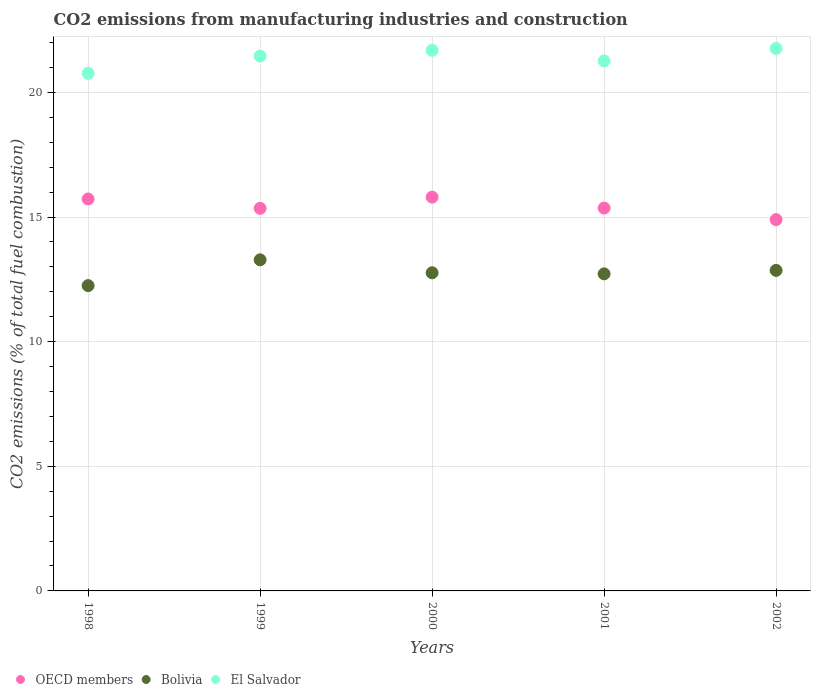How many different coloured dotlines are there?
Your answer should be compact. 3. Is the number of dotlines equal to the number of legend labels?
Offer a very short reply. Yes. What is the amount of CO2 emitted in Bolivia in 1998?
Provide a succinct answer. 12.25. Across all years, what is the maximum amount of CO2 emitted in El Salvador?
Provide a short and direct response. 21.76. Across all years, what is the minimum amount of CO2 emitted in El Salvador?
Make the answer very short. 20.76. In which year was the amount of CO2 emitted in El Salvador maximum?
Offer a very short reply. 2002. What is the total amount of CO2 emitted in Bolivia in the graph?
Your answer should be very brief. 63.87. What is the difference between the amount of CO2 emitted in Bolivia in 1998 and that in 2002?
Provide a short and direct response. -0.61. What is the difference between the amount of CO2 emitted in Bolivia in 2002 and the amount of CO2 emitted in El Salvador in 1999?
Ensure brevity in your answer.  -8.6. What is the average amount of CO2 emitted in El Salvador per year?
Provide a short and direct response. 21.39. In the year 1999, what is the difference between the amount of CO2 emitted in Bolivia and amount of CO2 emitted in OECD members?
Your answer should be very brief. -2.07. What is the ratio of the amount of CO2 emitted in Bolivia in 2001 to that in 2002?
Provide a short and direct response. 0.99. Is the amount of CO2 emitted in El Salvador in 2000 less than that in 2002?
Make the answer very short. Yes. What is the difference between the highest and the second highest amount of CO2 emitted in El Salvador?
Your response must be concise. 0.07. What is the difference between the highest and the lowest amount of CO2 emitted in El Salvador?
Keep it short and to the point. 1. In how many years, is the amount of CO2 emitted in Bolivia greater than the average amount of CO2 emitted in Bolivia taken over all years?
Provide a succinct answer. 2. Is it the case that in every year, the sum of the amount of CO2 emitted in OECD members and amount of CO2 emitted in El Salvador  is greater than the amount of CO2 emitted in Bolivia?
Ensure brevity in your answer.  Yes. Does the amount of CO2 emitted in El Salvador monotonically increase over the years?
Give a very brief answer. No. Is the amount of CO2 emitted in El Salvador strictly less than the amount of CO2 emitted in Bolivia over the years?
Give a very brief answer. No. How many years are there in the graph?
Your response must be concise. 5. What is the difference between two consecutive major ticks on the Y-axis?
Offer a very short reply. 5. Does the graph contain any zero values?
Provide a short and direct response. No. Does the graph contain grids?
Ensure brevity in your answer.  Yes. How many legend labels are there?
Your answer should be very brief. 3. How are the legend labels stacked?
Provide a succinct answer. Horizontal. What is the title of the graph?
Provide a short and direct response. CO2 emissions from manufacturing industries and construction. Does "Middle East & North Africa (all income levels)" appear as one of the legend labels in the graph?
Ensure brevity in your answer.  No. What is the label or title of the Y-axis?
Provide a short and direct response. CO2 emissions (% of total fuel combustion). What is the CO2 emissions (% of total fuel combustion) of OECD members in 1998?
Offer a very short reply. 15.72. What is the CO2 emissions (% of total fuel combustion) in Bolivia in 1998?
Your answer should be compact. 12.25. What is the CO2 emissions (% of total fuel combustion) in El Salvador in 1998?
Provide a short and direct response. 20.76. What is the CO2 emissions (% of total fuel combustion) in OECD members in 1999?
Your answer should be very brief. 15.35. What is the CO2 emissions (% of total fuel combustion) of Bolivia in 1999?
Keep it short and to the point. 13.28. What is the CO2 emissions (% of total fuel combustion) of El Salvador in 1999?
Give a very brief answer. 21.46. What is the CO2 emissions (% of total fuel combustion) in OECD members in 2000?
Make the answer very short. 15.8. What is the CO2 emissions (% of total fuel combustion) of Bolivia in 2000?
Your response must be concise. 12.76. What is the CO2 emissions (% of total fuel combustion) in El Salvador in 2000?
Provide a succinct answer. 21.69. What is the CO2 emissions (% of total fuel combustion) in OECD members in 2001?
Offer a terse response. 15.36. What is the CO2 emissions (% of total fuel combustion) in Bolivia in 2001?
Make the answer very short. 12.72. What is the CO2 emissions (% of total fuel combustion) of El Salvador in 2001?
Offer a terse response. 21.26. What is the CO2 emissions (% of total fuel combustion) in OECD members in 2002?
Make the answer very short. 14.9. What is the CO2 emissions (% of total fuel combustion) of Bolivia in 2002?
Your answer should be compact. 12.86. What is the CO2 emissions (% of total fuel combustion) of El Salvador in 2002?
Offer a terse response. 21.76. Across all years, what is the maximum CO2 emissions (% of total fuel combustion) of OECD members?
Ensure brevity in your answer.  15.8. Across all years, what is the maximum CO2 emissions (% of total fuel combustion) in Bolivia?
Ensure brevity in your answer.  13.28. Across all years, what is the maximum CO2 emissions (% of total fuel combustion) of El Salvador?
Offer a terse response. 21.76. Across all years, what is the minimum CO2 emissions (% of total fuel combustion) of OECD members?
Your response must be concise. 14.9. Across all years, what is the minimum CO2 emissions (% of total fuel combustion) in Bolivia?
Provide a short and direct response. 12.25. Across all years, what is the minimum CO2 emissions (% of total fuel combustion) of El Salvador?
Keep it short and to the point. 20.76. What is the total CO2 emissions (% of total fuel combustion) in OECD members in the graph?
Make the answer very short. 77.12. What is the total CO2 emissions (% of total fuel combustion) in Bolivia in the graph?
Your answer should be very brief. 63.87. What is the total CO2 emissions (% of total fuel combustion) of El Salvador in the graph?
Your response must be concise. 106.93. What is the difference between the CO2 emissions (% of total fuel combustion) of OECD members in 1998 and that in 1999?
Offer a very short reply. 0.38. What is the difference between the CO2 emissions (% of total fuel combustion) of Bolivia in 1998 and that in 1999?
Provide a short and direct response. -1.03. What is the difference between the CO2 emissions (% of total fuel combustion) of El Salvador in 1998 and that in 1999?
Make the answer very short. -0.69. What is the difference between the CO2 emissions (% of total fuel combustion) of OECD members in 1998 and that in 2000?
Your response must be concise. -0.07. What is the difference between the CO2 emissions (% of total fuel combustion) of Bolivia in 1998 and that in 2000?
Keep it short and to the point. -0.52. What is the difference between the CO2 emissions (% of total fuel combustion) in El Salvador in 1998 and that in 2000?
Provide a succinct answer. -0.93. What is the difference between the CO2 emissions (% of total fuel combustion) of OECD members in 1998 and that in 2001?
Ensure brevity in your answer.  0.37. What is the difference between the CO2 emissions (% of total fuel combustion) in Bolivia in 1998 and that in 2001?
Give a very brief answer. -0.47. What is the difference between the CO2 emissions (% of total fuel combustion) in El Salvador in 1998 and that in 2001?
Give a very brief answer. -0.5. What is the difference between the CO2 emissions (% of total fuel combustion) of OECD members in 1998 and that in 2002?
Provide a short and direct response. 0.83. What is the difference between the CO2 emissions (% of total fuel combustion) of Bolivia in 1998 and that in 2002?
Offer a terse response. -0.61. What is the difference between the CO2 emissions (% of total fuel combustion) of El Salvador in 1998 and that in 2002?
Your answer should be very brief. -1. What is the difference between the CO2 emissions (% of total fuel combustion) of OECD members in 1999 and that in 2000?
Keep it short and to the point. -0.45. What is the difference between the CO2 emissions (% of total fuel combustion) of Bolivia in 1999 and that in 2000?
Provide a short and direct response. 0.52. What is the difference between the CO2 emissions (% of total fuel combustion) in El Salvador in 1999 and that in 2000?
Your answer should be compact. -0.23. What is the difference between the CO2 emissions (% of total fuel combustion) in OECD members in 1999 and that in 2001?
Make the answer very short. -0.01. What is the difference between the CO2 emissions (% of total fuel combustion) of Bolivia in 1999 and that in 2001?
Give a very brief answer. 0.56. What is the difference between the CO2 emissions (% of total fuel combustion) in El Salvador in 1999 and that in 2001?
Offer a very short reply. 0.19. What is the difference between the CO2 emissions (% of total fuel combustion) in OECD members in 1999 and that in 2002?
Your answer should be very brief. 0.45. What is the difference between the CO2 emissions (% of total fuel combustion) in Bolivia in 1999 and that in 2002?
Keep it short and to the point. 0.42. What is the difference between the CO2 emissions (% of total fuel combustion) of El Salvador in 1999 and that in 2002?
Make the answer very short. -0.31. What is the difference between the CO2 emissions (% of total fuel combustion) in OECD members in 2000 and that in 2001?
Your answer should be compact. 0.44. What is the difference between the CO2 emissions (% of total fuel combustion) in Bolivia in 2000 and that in 2001?
Offer a terse response. 0.04. What is the difference between the CO2 emissions (% of total fuel combustion) in El Salvador in 2000 and that in 2001?
Offer a very short reply. 0.43. What is the difference between the CO2 emissions (% of total fuel combustion) in OECD members in 2000 and that in 2002?
Offer a terse response. 0.9. What is the difference between the CO2 emissions (% of total fuel combustion) in Bolivia in 2000 and that in 2002?
Provide a succinct answer. -0.1. What is the difference between the CO2 emissions (% of total fuel combustion) of El Salvador in 2000 and that in 2002?
Keep it short and to the point. -0.07. What is the difference between the CO2 emissions (% of total fuel combustion) in OECD members in 2001 and that in 2002?
Your response must be concise. 0.46. What is the difference between the CO2 emissions (% of total fuel combustion) in Bolivia in 2001 and that in 2002?
Provide a short and direct response. -0.14. What is the difference between the CO2 emissions (% of total fuel combustion) in El Salvador in 2001 and that in 2002?
Your response must be concise. -0.5. What is the difference between the CO2 emissions (% of total fuel combustion) of OECD members in 1998 and the CO2 emissions (% of total fuel combustion) of Bolivia in 1999?
Offer a very short reply. 2.44. What is the difference between the CO2 emissions (% of total fuel combustion) of OECD members in 1998 and the CO2 emissions (% of total fuel combustion) of El Salvador in 1999?
Your response must be concise. -5.73. What is the difference between the CO2 emissions (% of total fuel combustion) of Bolivia in 1998 and the CO2 emissions (% of total fuel combustion) of El Salvador in 1999?
Provide a succinct answer. -9.21. What is the difference between the CO2 emissions (% of total fuel combustion) in OECD members in 1998 and the CO2 emissions (% of total fuel combustion) in Bolivia in 2000?
Your answer should be compact. 2.96. What is the difference between the CO2 emissions (% of total fuel combustion) in OECD members in 1998 and the CO2 emissions (% of total fuel combustion) in El Salvador in 2000?
Keep it short and to the point. -5.97. What is the difference between the CO2 emissions (% of total fuel combustion) in Bolivia in 1998 and the CO2 emissions (% of total fuel combustion) in El Salvador in 2000?
Give a very brief answer. -9.44. What is the difference between the CO2 emissions (% of total fuel combustion) in OECD members in 1998 and the CO2 emissions (% of total fuel combustion) in Bolivia in 2001?
Offer a terse response. 3. What is the difference between the CO2 emissions (% of total fuel combustion) of OECD members in 1998 and the CO2 emissions (% of total fuel combustion) of El Salvador in 2001?
Offer a very short reply. -5.54. What is the difference between the CO2 emissions (% of total fuel combustion) of Bolivia in 1998 and the CO2 emissions (% of total fuel combustion) of El Salvador in 2001?
Make the answer very short. -9.01. What is the difference between the CO2 emissions (% of total fuel combustion) in OECD members in 1998 and the CO2 emissions (% of total fuel combustion) in Bolivia in 2002?
Your answer should be very brief. 2.86. What is the difference between the CO2 emissions (% of total fuel combustion) of OECD members in 1998 and the CO2 emissions (% of total fuel combustion) of El Salvador in 2002?
Your answer should be very brief. -6.04. What is the difference between the CO2 emissions (% of total fuel combustion) in Bolivia in 1998 and the CO2 emissions (% of total fuel combustion) in El Salvador in 2002?
Provide a short and direct response. -9.51. What is the difference between the CO2 emissions (% of total fuel combustion) in OECD members in 1999 and the CO2 emissions (% of total fuel combustion) in Bolivia in 2000?
Your answer should be compact. 2.58. What is the difference between the CO2 emissions (% of total fuel combustion) in OECD members in 1999 and the CO2 emissions (% of total fuel combustion) in El Salvador in 2000?
Provide a succinct answer. -6.34. What is the difference between the CO2 emissions (% of total fuel combustion) in Bolivia in 1999 and the CO2 emissions (% of total fuel combustion) in El Salvador in 2000?
Ensure brevity in your answer.  -8.41. What is the difference between the CO2 emissions (% of total fuel combustion) in OECD members in 1999 and the CO2 emissions (% of total fuel combustion) in Bolivia in 2001?
Offer a terse response. 2.63. What is the difference between the CO2 emissions (% of total fuel combustion) of OECD members in 1999 and the CO2 emissions (% of total fuel combustion) of El Salvador in 2001?
Your answer should be very brief. -5.91. What is the difference between the CO2 emissions (% of total fuel combustion) in Bolivia in 1999 and the CO2 emissions (% of total fuel combustion) in El Salvador in 2001?
Ensure brevity in your answer.  -7.98. What is the difference between the CO2 emissions (% of total fuel combustion) in OECD members in 1999 and the CO2 emissions (% of total fuel combustion) in Bolivia in 2002?
Your response must be concise. 2.49. What is the difference between the CO2 emissions (% of total fuel combustion) in OECD members in 1999 and the CO2 emissions (% of total fuel combustion) in El Salvador in 2002?
Give a very brief answer. -6.41. What is the difference between the CO2 emissions (% of total fuel combustion) of Bolivia in 1999 and the CO2 emissions (% of total fuel combustion) of El Salvador in 2002?
Your answer should be compact. -8.48. What is the difference between the CO2 emissions (% of total fuel combustion) in OECD members in 2000 and the CO2 emissions (% of total fuel combustion) in Bolivia in 2001?
Your answer should be compact. 3.08. What is the difference between the CO2 emissions (% of total fuel combustion) of OECD members in 2000 and the CO2 emissions (% of total fuel combustion) of El Salvador in 2001?
Keep it short and to the point. -5.46. What is the difference between the CO2 emissions (% of total fuel combustion) in Bolivia in 2000 and the CO2 emissions (% of total fuel combustion) in El Salvador in 2001?
Make the answer very short. -8.5. What is the difference between the CO2 emissions (% of total fuel combustion) of OECD members in 2000 and the CO2 emissions (% of total fuel combustion) of Bolivia in 2002?
Ensure brevity in your answer.  2.94. What is the difference between the CO2 emissions (% of total fuel combustion) of OECD members in 2000 and the CO2 emissions (% of total fuel combustion) of El Salvador in 2002?
Give a very brief answer. -5.96. What is the difference between the CO2 emissions (% of total fuel combustion) in Bolivia in 2000 and the CO2 emissions (% of total fuel combustion) in El Salvador in 2002?
Your answer should be very brief. -9. What is the difference between the CO2 emissions (% of total fuel combustion) in OECD members in 2001 and the CO2 emissions (% of total fuel combustion) in Bolivia in 2002?
Provide a succinct answer. 2.5. What is the difference between the CO2 emissions (% of total fuel combustion) in OECD members in 2001 and the CO2 emissions (% of total fuel combustion) in El Salvador in 2002?
Ensure brevity in your answer.  -6.4. What is the difference between the CO2 emissions (% of total fuel combustion) in Bolivia in 2001 and the CO2 emissions (% of total fuel combustion) in El Salvador in 2002?
Your answer should be very brief. -9.04. What is the average CO2 emissions (% of total fuel combustion) in OECD members per year?
Provide a succinct answer. 15.42. What is the average CO2 emissions (% of total fuel combustion) in Bolivia per year?
Ensure brevity in your answer.  12.77. What is the average CO2 emissions (% of total fuel combustion) in El Salvador per year?
Your response must be concise. 21.39. In the year 1998, what is the difference between the CO2 emissions (% of total fuel combustion) of OECD members and CO2 emissions (% of total fuel combustion) of Bolivia?
Your response must be concise. 3.48. In the year 1998, what is the difference between the CO2 emissions (% of total fuel combustion) of OECD members and CO2 emissions (% of total fuel combustion) of El Salvador?
Offer a terse response. -5.04. In the year 1998, what is the difference between the CO2 emissions (% of total fuel combustion) of Bolivia and CO2 emissions (% of total fuel combustion) of El Salvador?
Provide a short and direct response. -8.51. In the year 1999, what is the difference between the CO2 emissions (% of total fuel combustion) in OECD members and CO2 emissions (% of total fuel combustion) in Bolivia?
Your answer should be very brief. 2.07. In the year 1999, what is the difference between the CO2 emissions (% of total fuel combustion) in OECD members and CO2 emissions (% of total fuel combustion) in El Salvador?
Your answer should be very brief. -6.11. In the year 1999, what is the difference between the CO2 emissions (% of total fuel combustion) in Bolivia and CO2 emissions (% of total fuel combustion) in El Salvador?
Your response must be concise. -8.17. In the year 2000, what is the difference between the CO2 emissions (% of total fuel combustion) of OECD members and CO2 emissions (% of total fuel combustion) of Bolivia?
Provide a short and direct response. 3.03. In the year 2000, what is the difference between the CO2 emissions (% of total fuel combustion) of OECD members and CO2 emissions (% of total fuel combustion) of El Salvador?
Offer a very short reply. -5.89. In the year 2000, what is the difference between the CO2 emissions (% of total fuel combustion) in Bolivia and CO2 emissions (% of total fuel combustion) in El Salvador?
Provide a succinct answer. -8.93. In the year 2001, what is the difference between the CO2 emissions (% of total fuel combustion) in OECD members and CO2 emissions (% of total fuel combustion) in Bolivia?
Your answer should be compact. 2.64. In the year 2001, what is the difference between the CO2 emissions (% of total fuel combustion) of OECD members and CO2 emissions (% of total fuel combustion) of El Salvador?
Offer a terse response. -5.9. In the year 2001, what is the difference between the CO2 emissions (% of total fuel combustion) in Bolivia and CO2 emissions (% of total fuel combustion) in El Salvador?
Offer a very short reply. -8.54. In the year 2002, what is the difference between the CO2 emissions (% of total fuel combustion) of OECD members and CO2 emissions (% of total fuel combustion) of Bolivia?
Make the answer very short. 2.04. In the year 2002, what is the difference between the CO2 emissions (% of total fuel combustion) in OECD members and CO2 emissions (% of total fuel combustion) in El Salvador?
Ensure brevity in your answer.  -6.87. In the year 2002, what is the difference between the CO2 emissions (% of total fuel combustion) in Bolivia and CO2 emissions (% of total fuel combustion) in El Salvador?
Make the answer very short. -8.9. What is the ratio of the CO2 emissions (% of total fuel combustion) of OECD members in 1998 to that in 1999?
Give a very brief answer. 1.02. What is the ratio of the CO2 emissions (% of total fuel combustion) of Bolivia in 1998 to that in 1999?
Your response must be concise. 0.92. What is the ratio of the CO2 emissions (% of total fuel combustion) of El Salvador in 1998 to that in 1999?
Keep it short and to the point. 0.97. What is the ratio of the CO2 emissions (% of total fuel combustion) in OECD members in 1998 to that in 2000?
Ensure brevity in your answer.  1. What is the ratio of the CO2 emissions (% of total fuel combustion) in Bolivia in 1998 to that in 2000?
Your answer should be very brief. 0.96. What is the ratio of the CO2 emissions (% of total fuel combustion) of El Salvador in 1998 to that in 2000?
Ensure brevity in your answer.  0.96. What is the ratio of the CO2 emissions (% of total fuel combustion) of OECD members in 1998 to that in 2001?
Your answer should be very brief. 1.02. What is the ratio of the CO2 emissions (% of total fuel combustion) of Bolivia in 1998 to that in 2001?
Offer a very short reply. 0.96. What is the ratio of the CO2 emissions (% of total fuel combustion) in El Salvador in 1998 to that in 2001?
Make the answer very short. 0.98. What is the ratio of the CO2 emissions (% of total fuel combustion) in OECD members in 1998 to that in 2002?
Offer a very short reply. 1.06. What is the ratio of the CO2 emissions (% of total fuel combustion) in Bolivia in 1998 to that in 2002?
Provide a succinct answer. 0.95. What is the ratio of the CO2 emissions (% of total fuel combustion) of El Salvador in 1998 to that in 2002?
Offer a terse response. 0.95. What is the ratio of the CO2 emissions (% of total fuel combustion) of OECD members in 1999 to that in 2000?
Give a very brief answer. 0.97. What is the ratio of the CO2 emissions (% of total fuel combustion) in Bolivia in 1999 to that in 2000?
Your response must be concise. 1.04. What is the ratio of the CO2 emissions (% of total fuel combustion) of El Salvador in 1999 to that in 2000?
Offer a terse response. 0.99. What is the ratio of the CO2 emissions (% of total fuel combustion) in OECD members in 1999 to that in 2001?
Your answer should be compact. 1. What is the ratio of the CO2 emissions (% of total fuel combustion) in Bolivia in 1999 to that in 2001?
Offer a terse response. 1.04. What is the ratio of the CO2 emissions (% of total fuel combustion) of El Salvador in 1999 to that in 2001?
Provide a succinct answer. 1.01. What is the ratio of the CO2 emissions (% of total fuel combustion) of OECD members in 1999 to that in 2002?
Ensure brevity in your answer.  1.03. What is the ratio of the CO2 emissions (% of total fuel combustion) in Bolivia in 1999 to that in 2002?
Give a very brief answer. 1.03. What is the ratio of the CO2 emissions (% of total fuel combustion) in El Salvador in 1999 to that in 2002?
Provide a short and direct response. 0.99. What is the ratio of the CO2 emissions (% of total fuel combustion) in OECD members in 2000 to that in 2001?
Your answer should be very brief. 1.03. What is the ratio of the CO2 emissions (% of total fuel combustion) of El Salvador in 2000 to that in 2001?
Keep it short and to the point. 1.02. What is the ratio of the CO2 emissions (% of total fuel combustion) in OECD members in 2000 to that in 2002?
Offer a very short reply. 1.06. What is the ratio of the CO2 emissions (% of total fuel combustion) of OECD members in 2001 to that in 2002?
Ensure brevity in your answer.  1.03. What is the ratio of the CO2 emissions (% of total fuel combustion) of Bolivia in 2001 to that in 2002?
Offer a terse response. 0.99. What is the ratio of the CO2 emissions (% of total fuel combustion) of El Salvador in 2001 to that in 2002?
Your answer should be very brief. 0.98. What is the difference between the highest and the second highest CO2 emissions (% of total fuel combustion) in OECD members?
Your answer should be compact. 0.07. What is the difference between the highest and the second highest CO2 emissions (% of total fuel combustion) in Bolivia?
Provide a short and direct response. 0.42. What is the difference between the highest and the second highest CO2 emissions (% of total fuel combustion) of El Salvador?
Offer a very short reply. 0.07. What is the difference between the highest and the lowest CO2 emissions (% of total fuel combustion) in OECD members?
Provide a short and direct response. 0.9. What is the difference between the highest and the lowest CO2 emissions (% of total fuel combustion) of Bolivia?
Give a very brief answer. 1.03. 